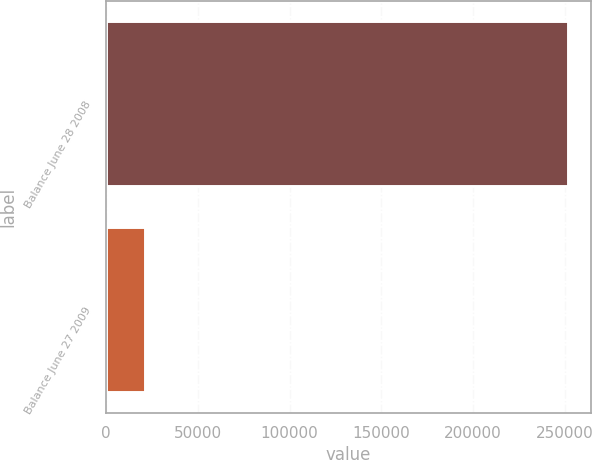Convert chart. <chart><loc_0><loc_0><loc_500><loc_500><bar_chart><fcel>Balance June 28 2008<fcel>Balance June 27 2009<nl><fcel>251478<fcel>21205<nl></chart> 